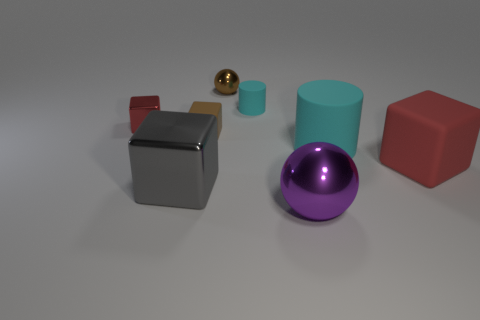How many tiny brown balls are in front of the shiny thing in front of the metallic block that is to the right of the small red thing?
Give a very brief answer. 0. There is a brown cube; what number of small shiny spheres are on the right side of it?
Your response must be concise. 1. What is the color of the metallic ball behind the cyan rubber cylinder that is on the left side of the large rubber cylinder?
Keep it short and to the point. Brown. What number of other things are there of the same material as the small brown block
Offer a very short reply. 3. Are there the same number of big gray metal cubes to the right of the tiny rubber cylinder and cyan rubber cylinders?
Provide a short and direct response. No. There is a ball in front of the shiny block that is left of the large cube left of the big cyan matte thing; what is its material?
Your answer should be compact. Metal. The sphere that is behind the small brown block is what color?
Ensure brevity in your answer.  Brown. Are there any other things that are the same shape as the purple metallic object?
Offer a very short reply. Yes. How big is the metallic object on the left side of the big cube that is left of the big cyan cylinder?
Give a very brief answer. Small. Are there the same number of shiny objects in front of the tiny red cube and big rubber things that are behind the red matte object?
Make the answer very short. No. 